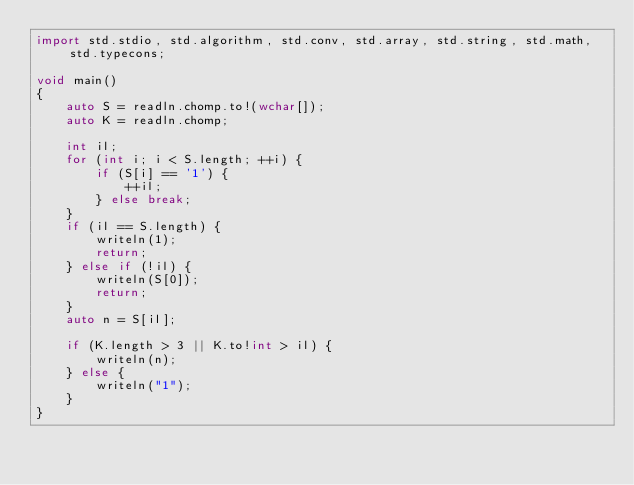<code> <loc_0><loc_0><loc_500><loc_500><_D_>import std.stdio, std.algorithm, std.conv, std.array, std.string, std.math, std.typecons;

void main()
{
    auto S = readln.chomp.to!(wchar[]);
    auto K = readln.chomp;

    int il;
    for (int i; i < S.length; ++i) {
        if (S[i] == '1') {
            ++il;
        } else break;
    }
    if (il == S.length) {
        writeln(1);
        return;
    } else if (!il) {
        writeln(S[0]);
        return;
    }
    auto n = S[il];

    if (K.length > 3 || K.to!int > il) {
        writeln(n);
    } else {
        writeln("1");
    }
}</code> 